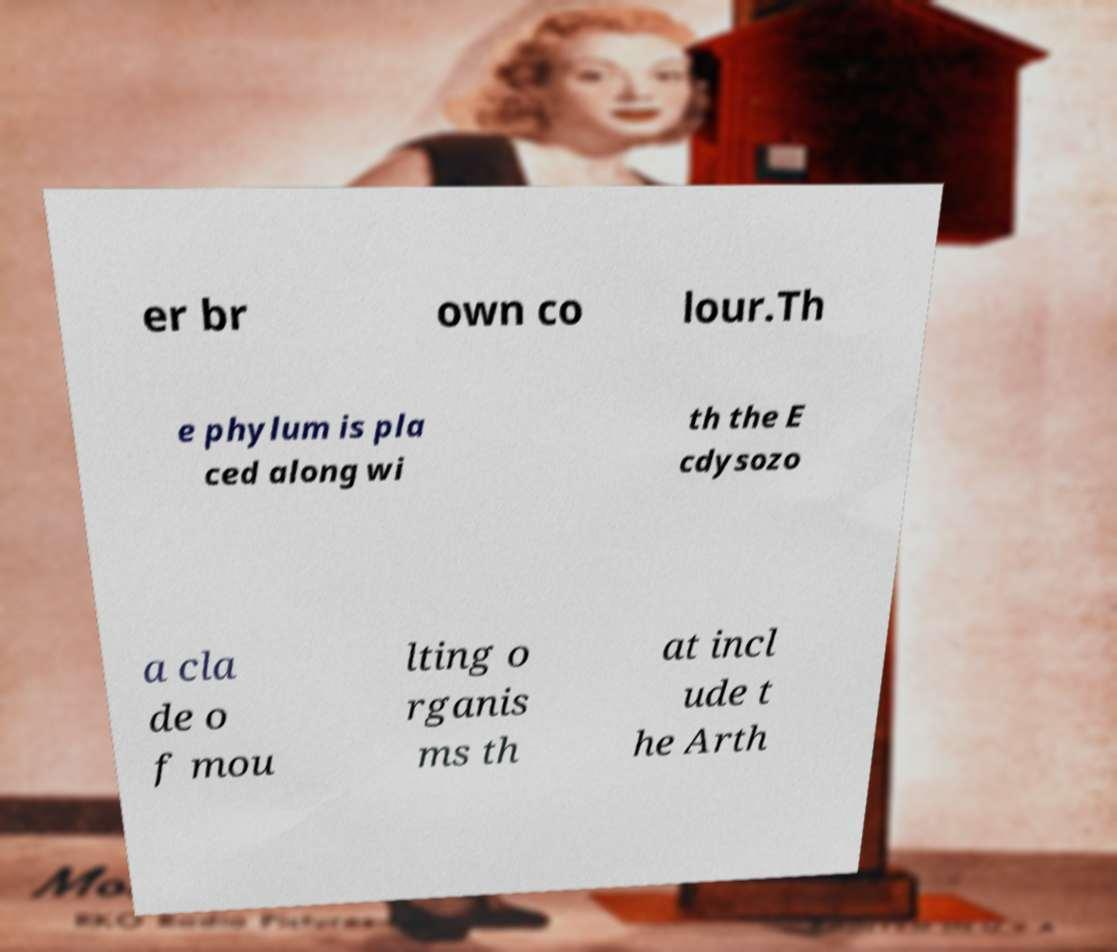There's text embedded in this image that I need extracted. Can you transcribe it verbatim? er br own co lour.Th e phylum is pla ced along wi th the E cdysozo a cla de o f mou lting o rganis ms th at incl ude t he Arth 